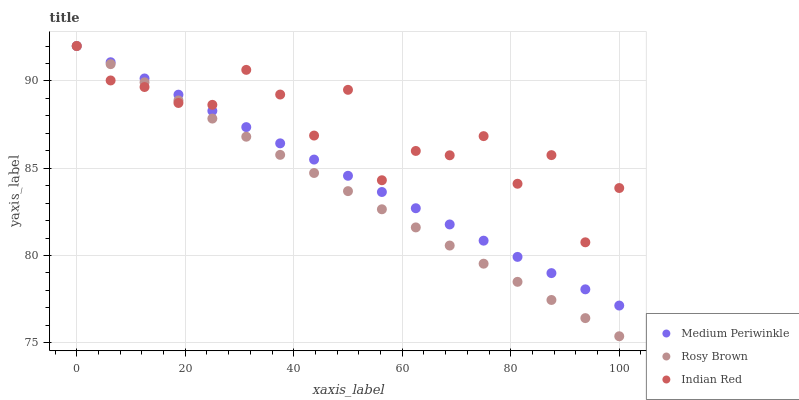Does Rosy Brown have the minimum area under the curve?
Answer yes or no. Yes. Does Indian Red have the maximum area under the curve?
Answer yes or no. Yes. Does Medium Periwinkle have the minimum area under the curve?
Answer yes or no. No. Does Medium Periwinkle have the maximum area under the curve?
Answer yes or no. No. Is Rosy Brown the smoothest?
Answer yes or no. Yes. Is Indian Red the roughest?
Answer yes or no. Yes. Is Medium Periwinkle the smoothest?
Answer yes or no. No. Is Medium Periwinkle the roughest?
Answer yes or no. No. Does Rosy Brown have the lowest value?
Answer yes or no. Yes. Does Medium Periwinkle have the lowest value?
Answer yes or no. No. Does Indian Red have the highest value?
Answer yes or no. Yes. Does Indian Red intersect Rosy Brown?
Answer yes or no. Yes. Is Indian Red less than Rosy Brown?
Answer yes or no. No. Is Indian Red greater than Rosy Brown?
Answer yes or no. No. 